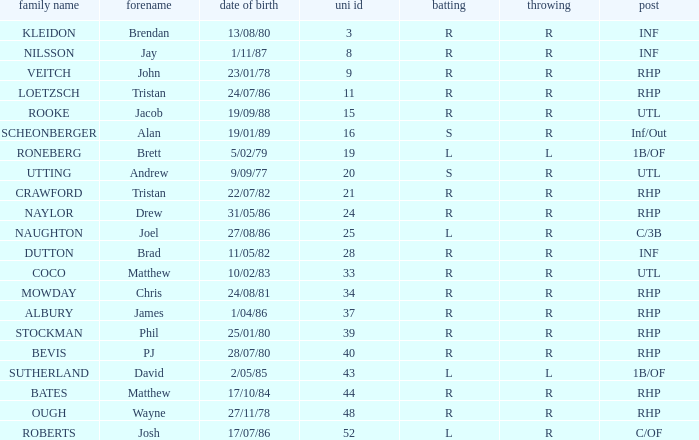Which First has a Uni # larger than 34, and Throws of r, and a Position of rhp, and a Surname of stockman? Phil. 